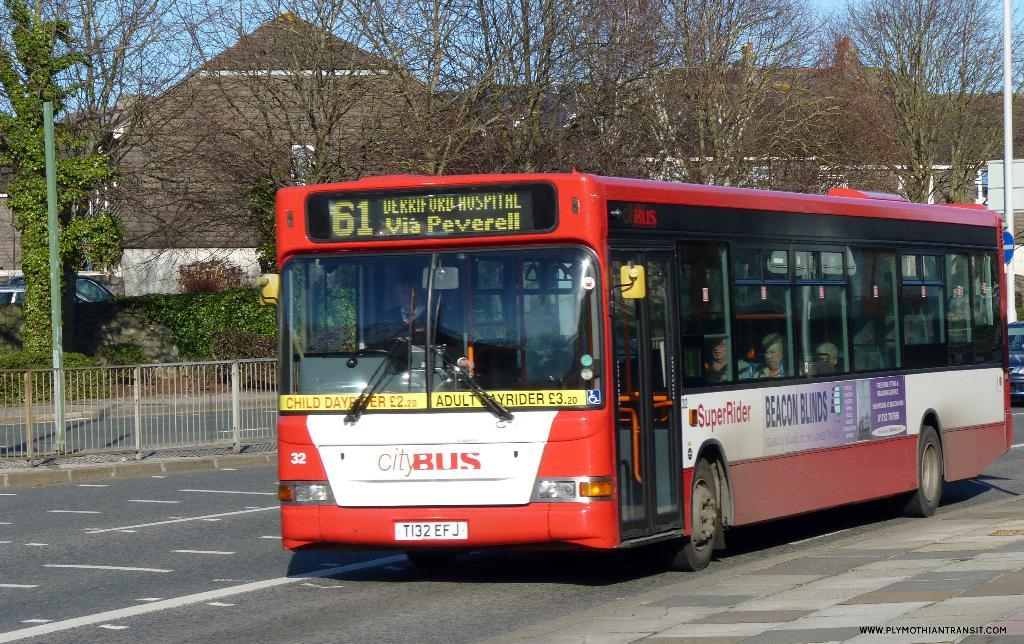What type of vehicles are present in the image? There are vehicles with text in the image. What can be seen in the background of the image? There is a railing, trees, buildings, and the sky visible in the background of the image. Is there any quicksand present in the image? There is no quicksand present in the image. What type of knowledge can be gained from the vehicles with text in the image? The vehicles with text in the image do not convey any specific knowledge; they are simply vehicles with text. 